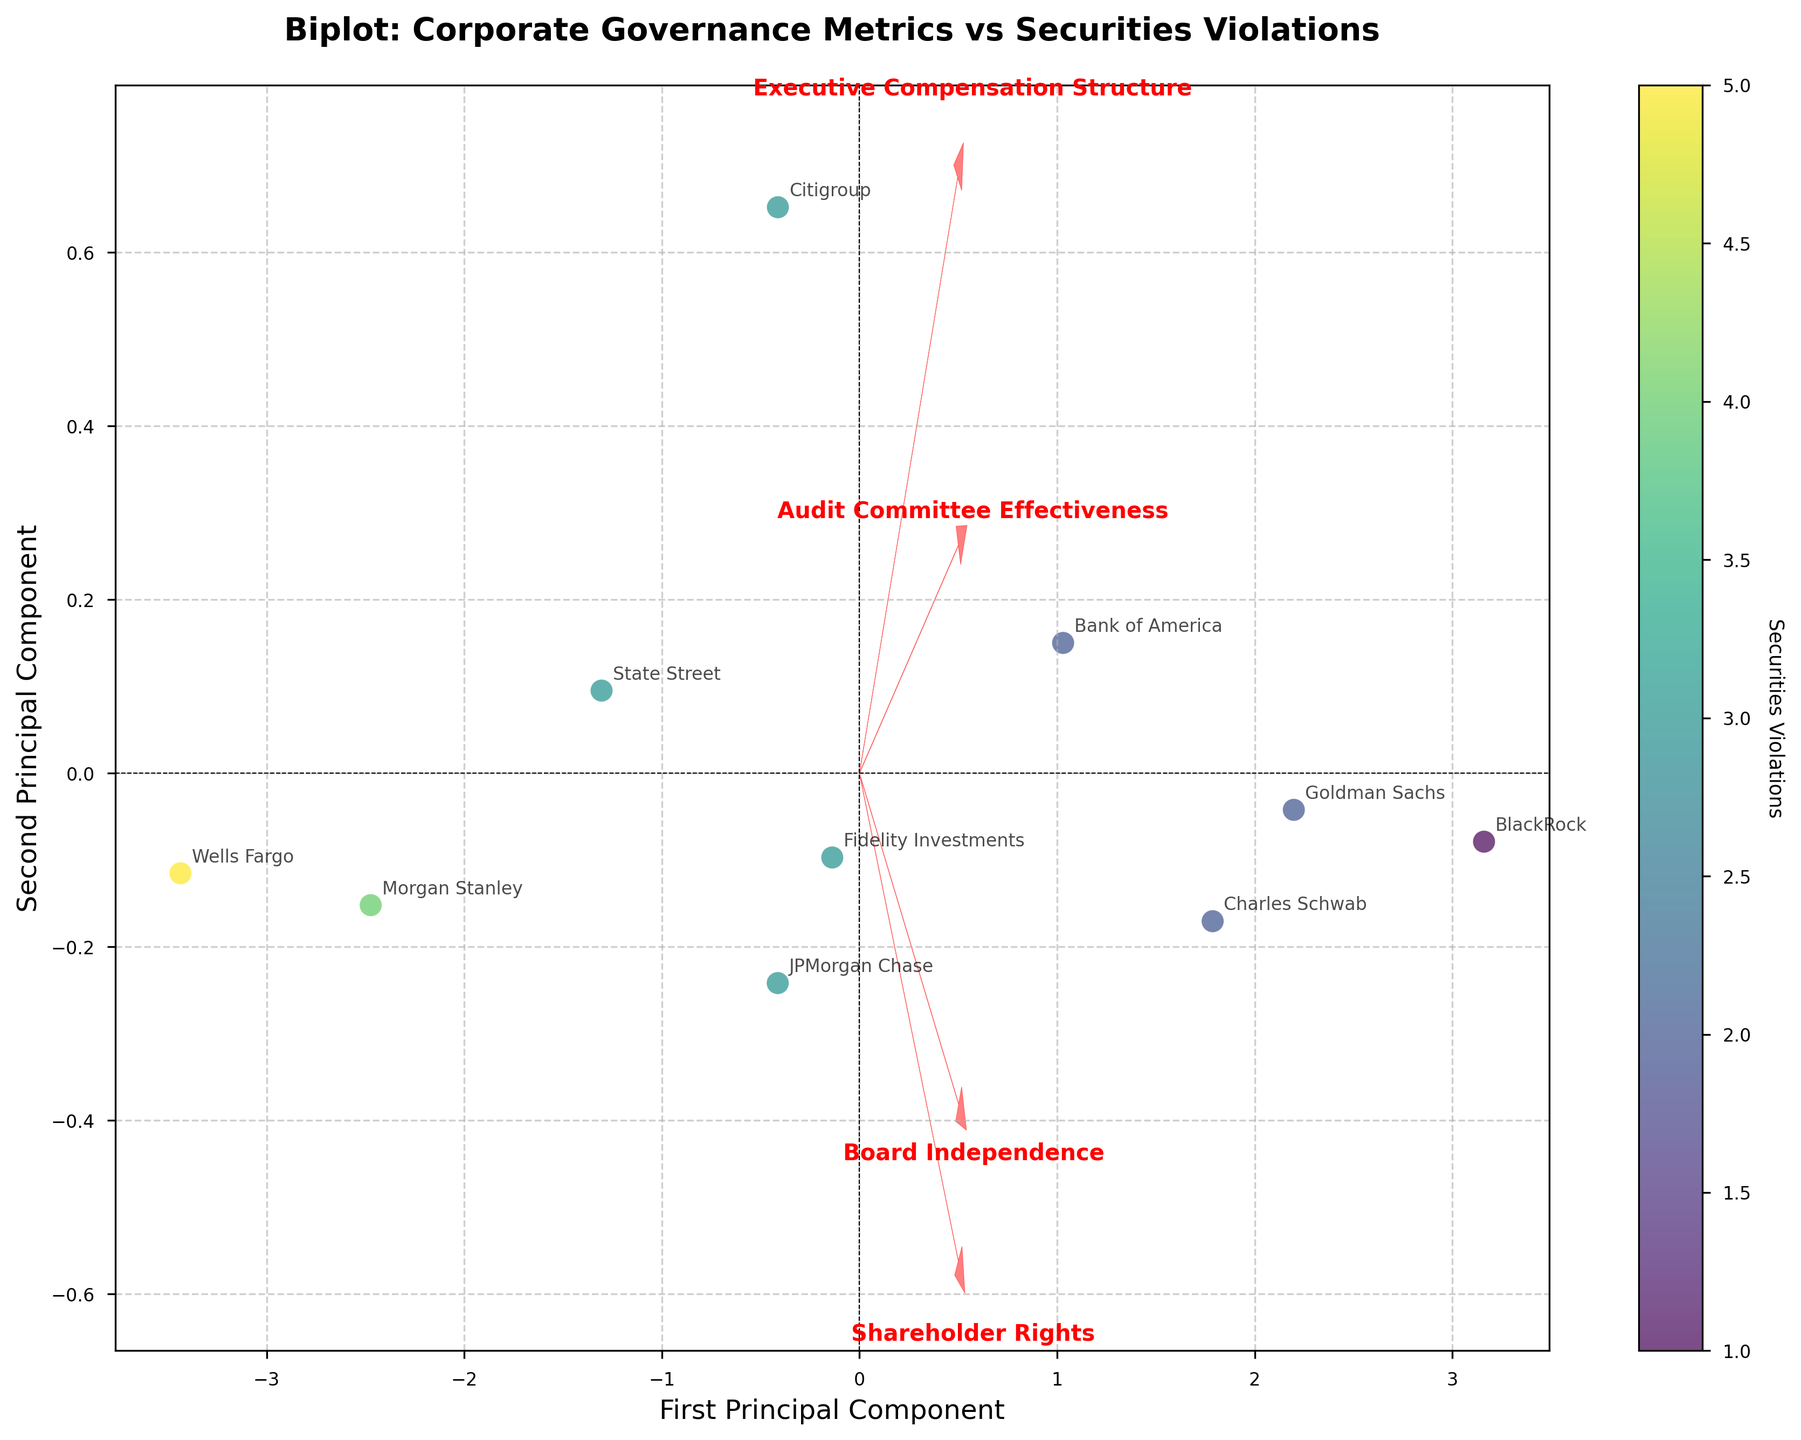What is the title of the plot? The title of the plot is usually displayed at the top of the figure. In this case, it should say "Biplot: Corporate Governance Metrics vs Securities Violations".
Answer: Biplot: Corporate Governance Metrics vs Securities Violations How many principal components are shown in the plot? The x-axis and y-axis labels indicate the number of principal components shown. They are labeled as "First Principal Component" and "Second Principal Component".
Answer: 2 Which company has the highest number of securities violations? The color of the data points indicates the number of securities violations. By identifying the darkest (or most clearly marked) data point and checking its label, we can see that Wells Fargo has the highest number of 5 violations.
Answer: Wells Fargo What does the colorbar represent? The colorbar typically indicates the variable mapped by the color of the data points. In this figure, the label on the colorbar specifies that it represents "Securities Violations".
Answer: Securities Violations Which feature has the largest vector on the biplot? The length of the arrows (vectors) extending from the origin indicates the magnitude of each feature's contribution to the principal components. The vector for "Audit Committee Effectiveness" seems to be the longest.
Answer: Audit Committee Effectiveness What is the relationship between "Board Independence" and the principal components? "Board Independence" has a significant positive projection on the first principal component and a lesser positive projection on the second principal component, as indicated by the direction and length of the arrow.
Answer: Positive on both components Identify two companies with similar principal component scores. By visually inspecting the plot, Goldman Sachs and Charles Schwab are closely clustered together, indicating similar principal component scores.
Answer: Goldman Sachs and Charles Schwab Which metric shows the least correlation with the second principal component? The arrow representing the vector for "Executive Compensation Structure" is shortest along the second principal component axis.
Answer: Executive Compensation Structure Is there an apparent trend between audit committee effectiveness and securities violations? By observing the direction of the "Audit Committee Effectiveness" arrow and the color gradient of the data points, companies with higher audit committee effectiveness (higher projection on the arrow) tend to have fewer securities violations (lighter color).
Answer: Higher audit committee effectiveness correlates with fewer violations 